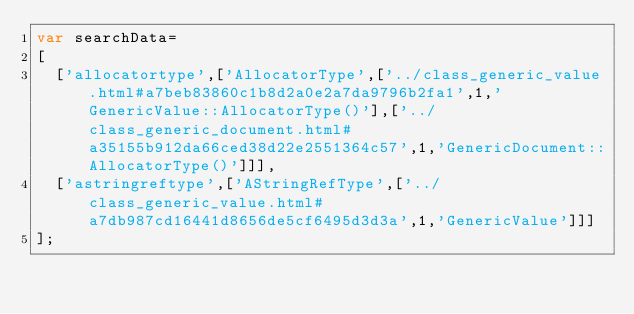<code> <loc_0><loc_0><loc_500><loc_500><_JavaScript_>var searchData=
[
  ['allocatortype',['AllocatorType',['../class_generic_value.html#a7beb83860c1b8d2a0e2a7da9796b2fa1',1,'GenericValue::AllocatorType()'],['../class_generic_document.html#a35155b912da66ced38d22e2551364c57',1,'GenericDocument::AllocatorType()']]],
  ['astringreftype',['AStringRefType',['../class_generic_value.html#a7db987cd16441d8656de5cf6495d3d3a',1,'GenericValue']]]
];
</code> 